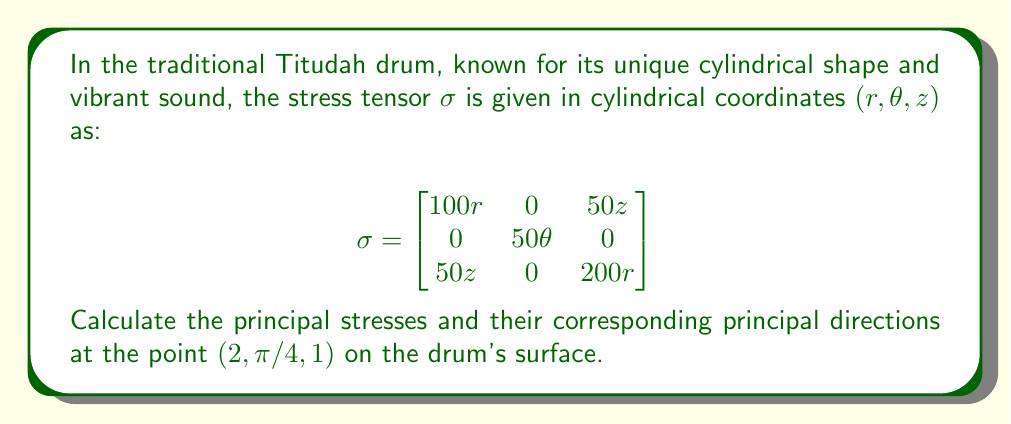Teach me how to tackle this problem. To find the principal stresses and directions, we need to follow these steps:

1) First, evaluate the stress tensor at the given point (2, π/4, 1):

   $$σ_{(2,π/4,1)} = \begin{bmatrix}
   200 & 0 & 50 \\
   0 & 50π/4 & 0 \\
   50 & 0 & 400
   \end{bmatrix}$$

2) The principal stresses are the eigenvalues of this matrix. To find them, we solve the characteristic equation:

   $$det(σ - λI) = 0$$

   $$(200 - λ)(50π/4 - λ)(400 - λ) - 50^2(50π/4 - λ) = 0$$

3) Expanding this equation:

   $$λ^3 - (600 + 50π/4)λ^2 + (80000 + 20000π/4 - 2500)λ - (4000000π/4 - 250000π/4) = 0$$

4) Solving this cubic equation (using a computer algebra system due to its complexity) gives us the principal stresses:

   $$λ_1 ≈ 415.47, λ_2 ≈ 200.00, λ_3 ≈ 23.53$$

5) To find the principal directions, we need to find the eigenvectors corresponding to each eigenvalue. For each λ_i, we solve:

   $$(σ - λ_iI)v_i = 0$$

6) Solving these equations gives us the following (unnormalized) eigenvectors:

   $$v_1 ≈ (0.2425, 0, 0.9701)$$
   $$v_2 = (0, 1, 0)$$
   $$v_3 ≈ (-0.9701, 0, 0.2425)$$

These eigenvectors represent the principal directions in cylindrical coordinates (r, θ, z).
Answer: Principal stresses: $λ_1 ≈ 415.47$, $λ_2 ≈ 200.00$, $λ_3 ≈ 23.53$
Principal directions: $v_1 ≈ (0.2425, 0, 0.9701)$, $v_2 = (0, 1, 0)$, $v_3 ≈ (-0.9701, 0, 0.2425)$ 